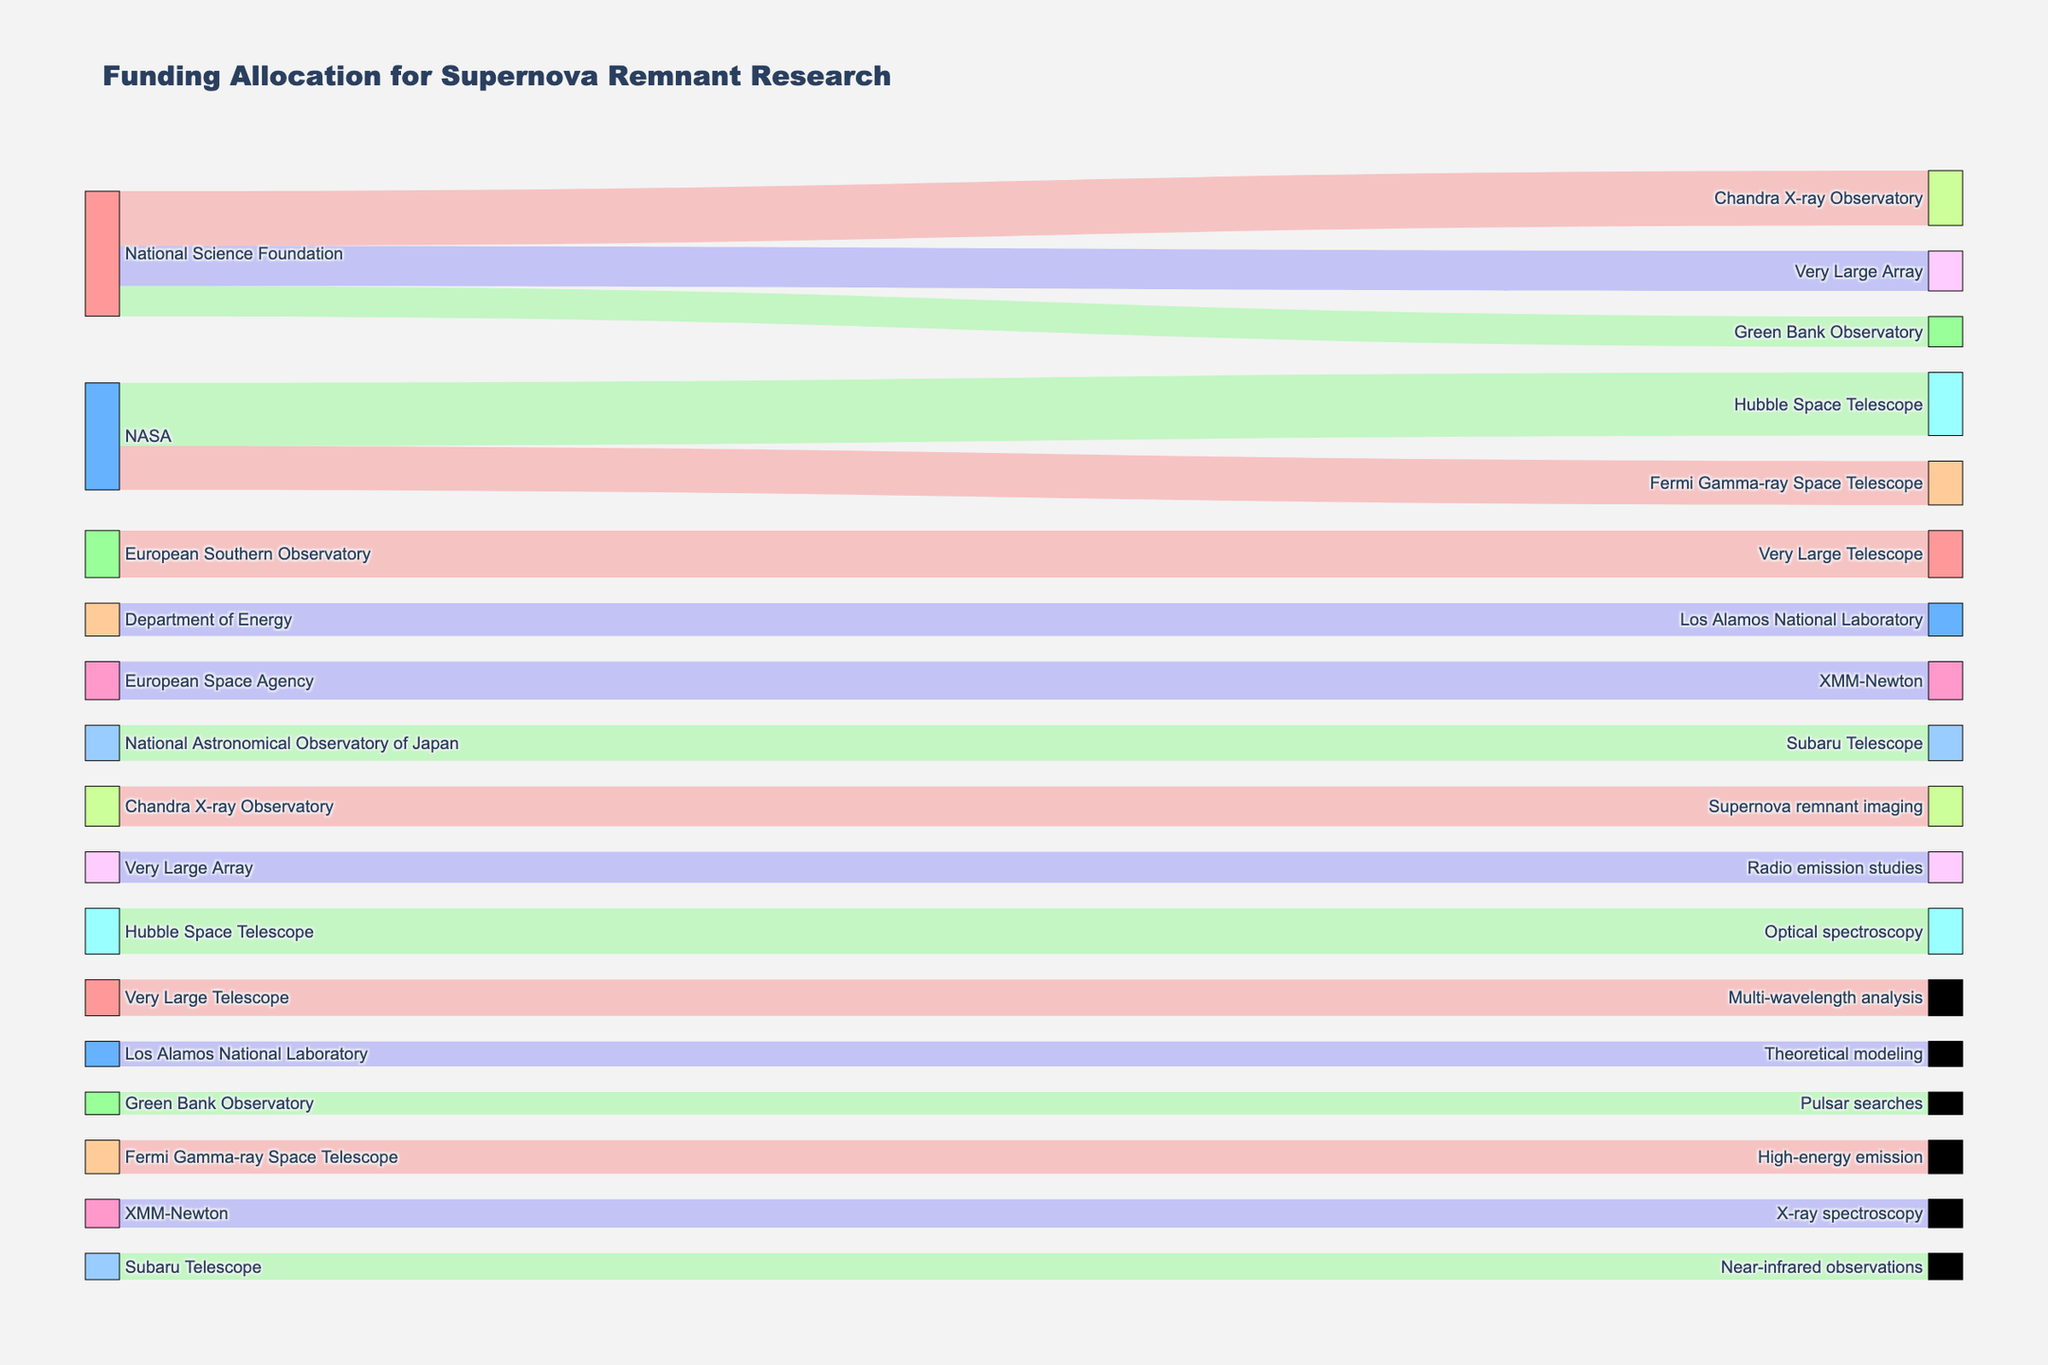What is the total funding allocated by the National Science Foundation? Identify all funding allocations from the National Science Foundation: Chandra X-ray Observatory ($8,500,000), Very Large Array ($6,200,000), Green Bank Observatory ($4,700,000). Sum these amounts: $8,500,000 + $6,200,000 + $4,700,000 = $19,400,000
Answer: $19,400,000 Which telescope received the highest funding from NASA? Examine the funding allocations from NASA: Hubble Space Telescope ($9,800,000) and Fermi Gamma-ray Space Telescope ($6,800,000). The Hubble Space Telescope received the highest funding.
Answer: Hubble Space Telescope What is the combined total funding for all projects under the Very Large Telescope? Identify funding directed to the Very Large Telescope: from European Southern Observatory ($7,300,000) and fund allocation for Multi-wavelength analysis ($5,600,000). Sum these amounts: $7,300,000 + $5,600,000 = $12,900,000
Answer: $12,900,000 Which observatory has the lowest funding allocated to its projects? List each observatory's total funding. The Department of Energy's Los Alamos National Laboratory ($5,100,000) has the lowest funding compared to others listed in the data.
Answer: Los Alamos National Laboratory What is the total funding allocated for X-ray spectroscopy? Locate and sum the funding for X-ray spectroscopy under its related observatory, XMM-Newton ($4,400,000). No additional related funding is listed.
Answer: $4,400,000 How does funding for Radio emission studies compare to Near-infrared observations? Compare the funding amounts: Radio emission studies ($4,800,000) and Near-infrared observations ($4,100,000). Radio emission studies have higher funding.
Answer: Radio emission studies have higher funding Which source contributes more funding to Green Bank Observatory, NASA or National Science Foundation? National Science Foundation allocates $4,700,000 to Green Bank Observatory, whereas NASA does not allocate any funding directly to Green Bank Observatory. Therefore, National Science Foundation contributes more.
Answer: National Science Foundation What percentage of the Chandra X-ray Observatory's funding is used for Supernova remnant imaging? Identify the funding allocated to Chandra X-ray Observatory ($8,500,000) and the portion used for Supernova remnant imaging ($6,200,000). Calculate the percentage: ($6,200,000 / $8,500,000) * 100 ≈ 72.94%
Answer: ≈ 72.94% 